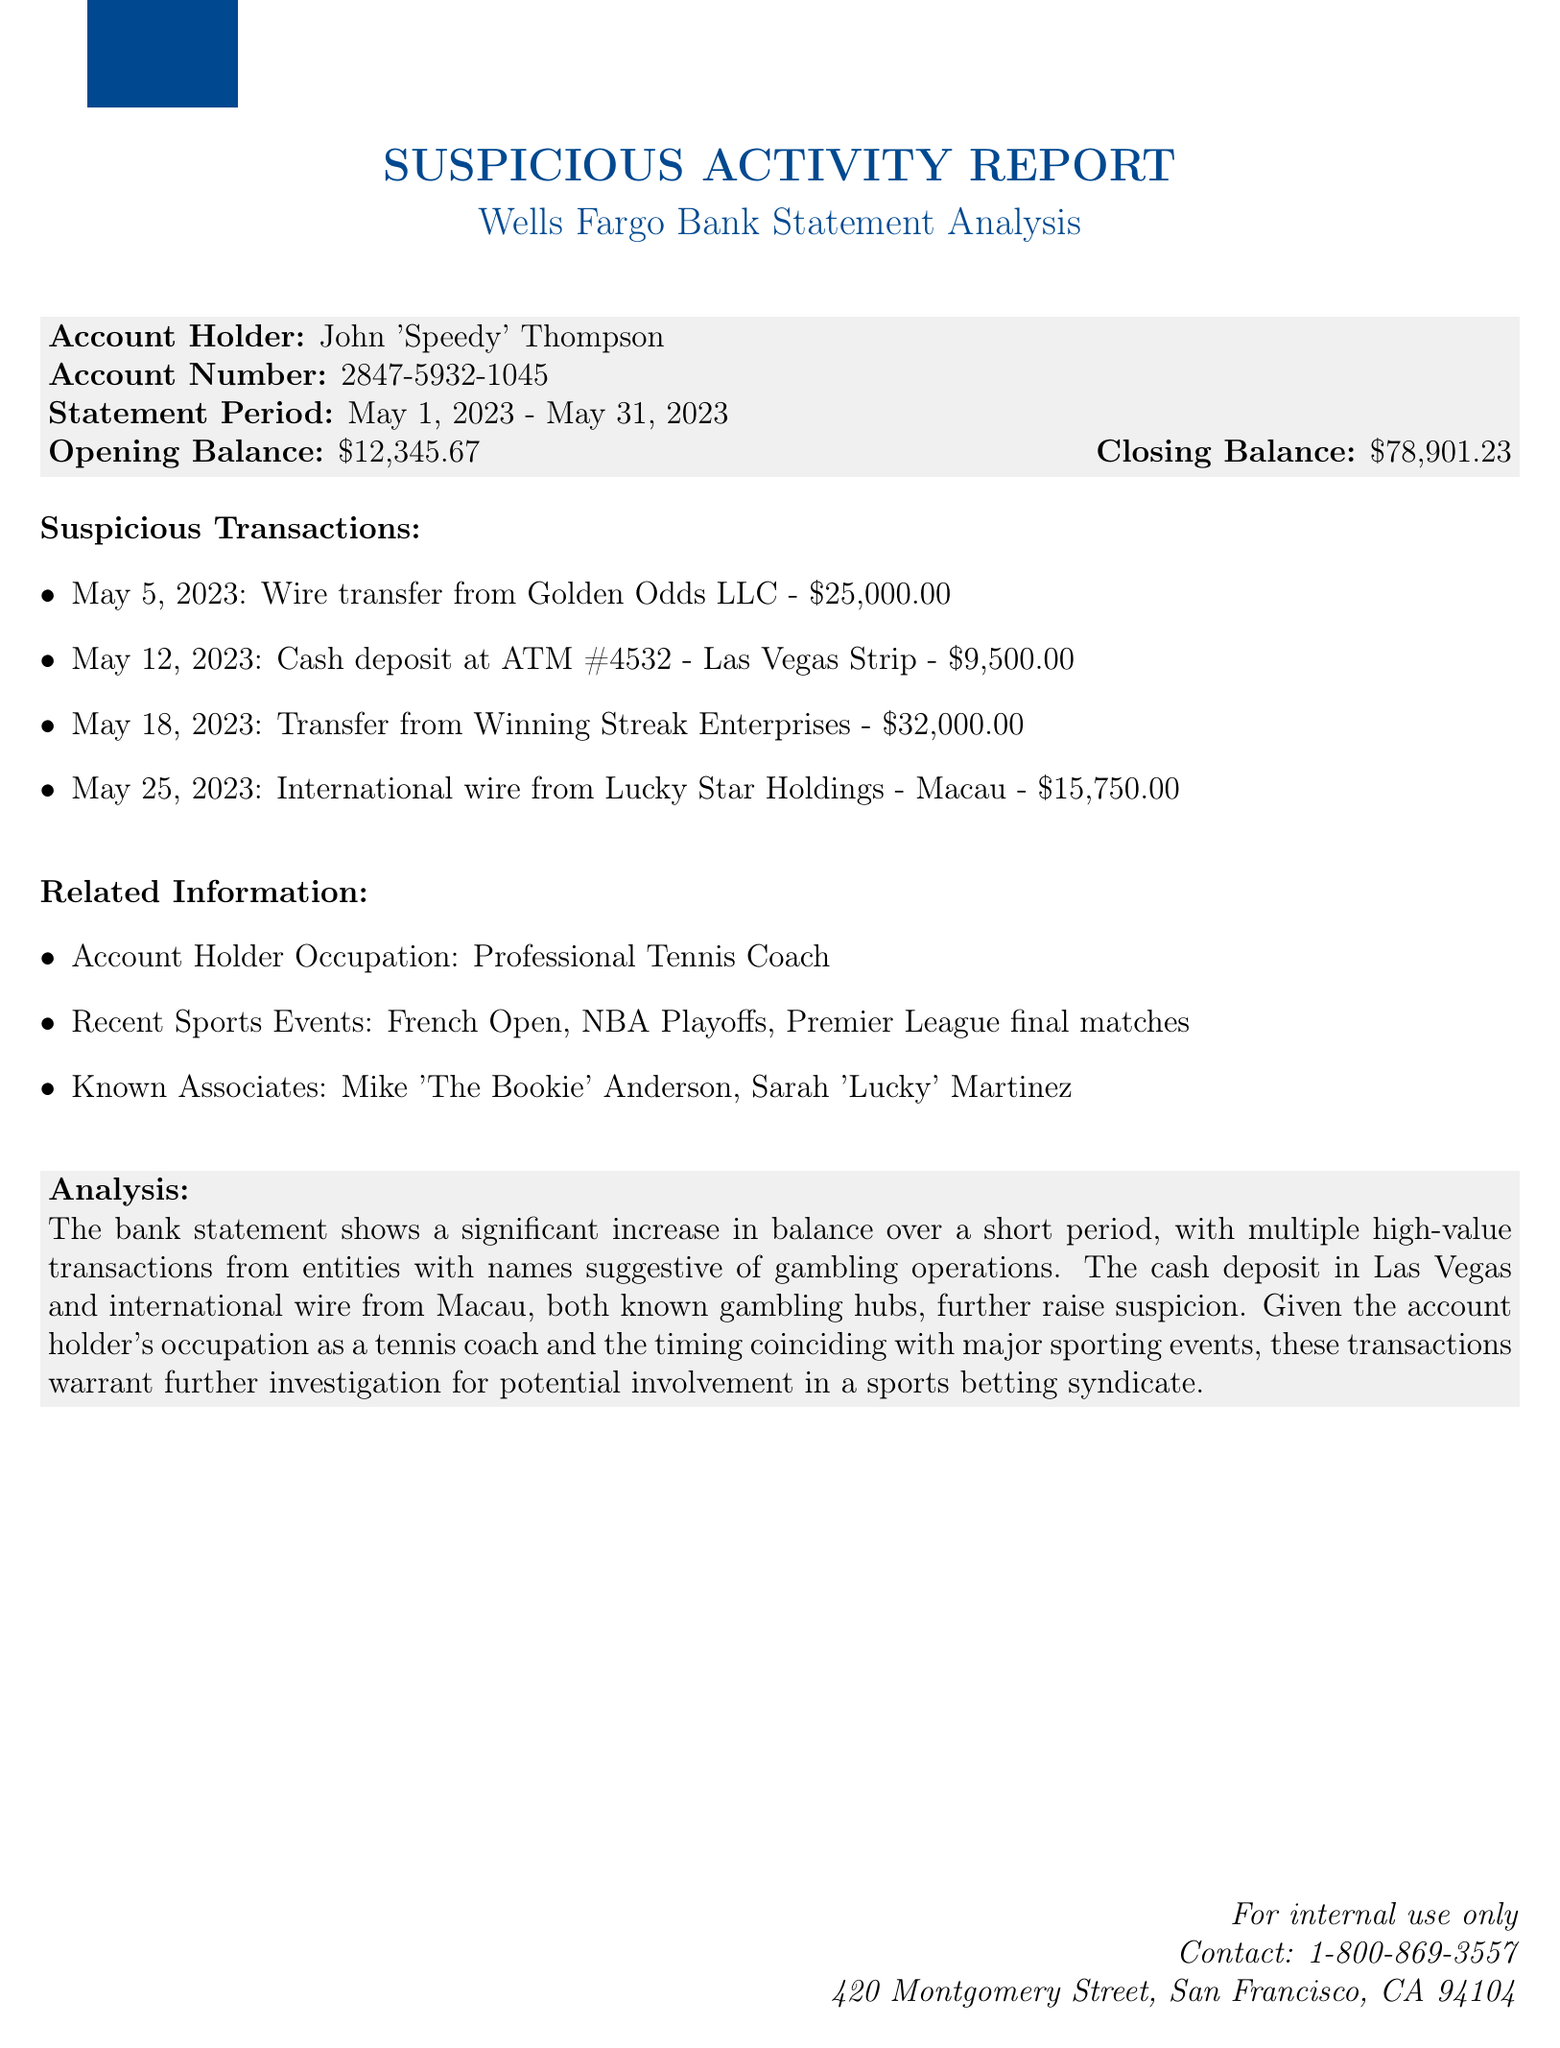What is the name of the bank? The bank mentioned in the document is identified as Wells Fargo.
Answer: Wells Fargo Who is the account holder? The document specifies the account holder's name as John 'Speedy' Thompson.
Answer: John 'Speedy' Thompson What was the opening balance? The opening balance is explicitly stated in the document as $12,345.67.
Answer: $12,345.67 How many suspicious transactions are listed? The document lists four specific suspicious transactions that occurred during the statement period.
Answer: Four What was the amount of the largest suspicious transaction? The largest suspicious transaction is a $32,000 transfer from Winning Streak Enterprises.
Answer: $32,000.00 When did the cash deposit at ATM #4532 occur? The document specifies that the cash deposit took place on May 12, 2023.
Answer: May 12, 2023 Which event coincided with the timing of the transactions? The transactions took place during major sporting events such as the French Open.
Answer: French Open What is the occupation of the account holder? The document states that the account holder is a Professional Tennis Coach.
Answer: Professional Tennis Coach Who are two known associates of the account holder? The known associates mentioned in the document include Mike 'The Bookie' Anderson and Sarah 'Lucky' Martinez.
Answer: Mike 'The Bookie' Anderson, Sarah 'Lucky' Martinez 